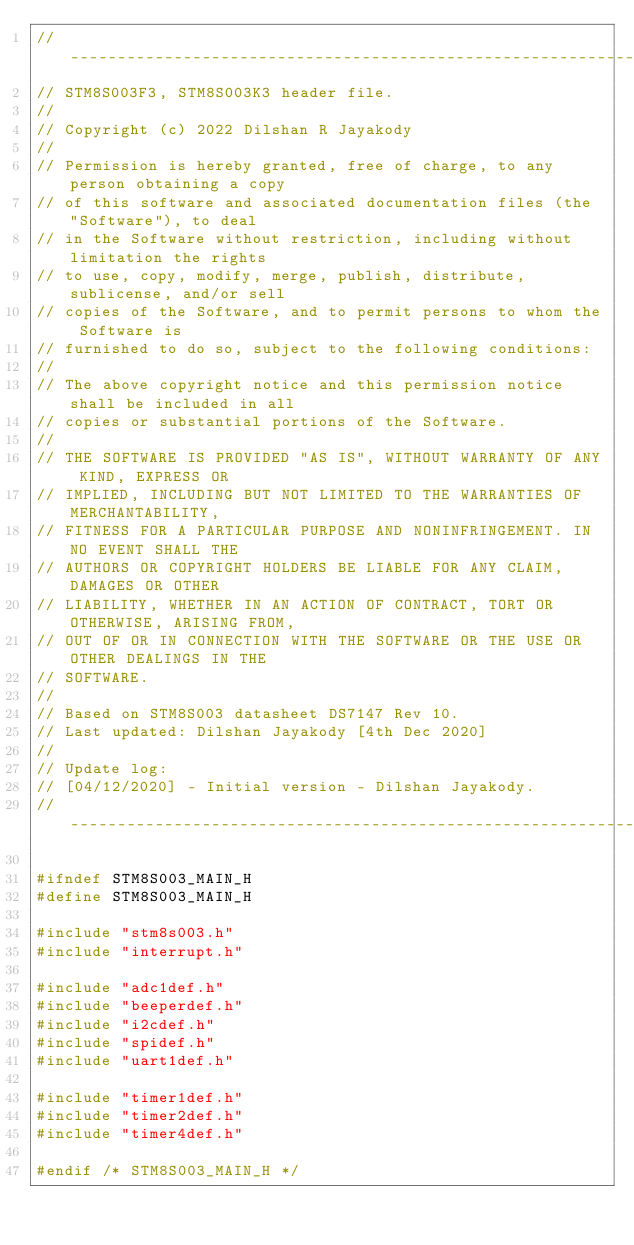Convert code to text. <code><loc_0><loc_0><loc_500><loc_500><_C_>//----------------------------------------------------------------------------------
// STM8S003F3, STM8S003K3 header file.
//
// Copyright (c) 2022 Dilshan R Jayakody
//
// Permission is hereby granted, free of charge, to any person obtaining a copy
// of this software and associated documentation files (the "Software"), to deal
// in the Software without restriction, including without limitation the rights
// to use, copy, modify, merge, publish, distribute, sublicense, and/or sell
// copies of the Software, and to permit persons to whom the Software is
// furnished to do so, subject to the following conditions:
// 
// The above copyright notice and this permission notice shall be included in all
// copies or substantial portions of the Software.
// 
// THE SOFTWARE IS PROVIDED "AS IS", WITHOUT WARRANTY OF ANY KIND, EXPRESS OR
// IMPLIED, INCLUDING BUT NOT LIMITED TO THE WARRANTIES OF MERCHANTABILITY,
// FITNESS FOR A PARTICULAR PURPOSE AND NONINFRINGEMENT. IN NO EVENT SHALL THE
// AUTHORS OR COPYRIGHT HOLDERS BE LIABLE FOR ANY CLAIM, DAMAGES OR OTHER
// LIABILITY, WHETHER IN AN ACTION OF CONTRACT, TORT OR OTHERWISE, ARISING FROM,
// OUT OF OR IN CONNECTION WITH THE SOFTWARE OR THE USE OR OTHER DEALINGS IN THE
// SOFTWARE.
//  
// Based on STM8S003 datasheet DS7147 Rev 10.
// Last updated: Dilshan Jayakody [4th Dec 2020]
//
// Update log:
// [04/12/2020] - Initial version - Dilshan Jayakody.
//----------------------------------------------------------------------------------

#ifndef STM8S003_MAIN_H
#define STM8S003_MAIN_H

#include "stm8s003.h"
#include "interrupt.h"

#include "adc1def.h"
#include "beeperdef.h"
#include "i2cdef.h"
#include "spidef.h"
#include "uart1def.h"

#include "timer1def.h"
#include "timer2def.h"
#include "timer4def.h"

#endif /* STM8S003_MAIN_H */</code> 